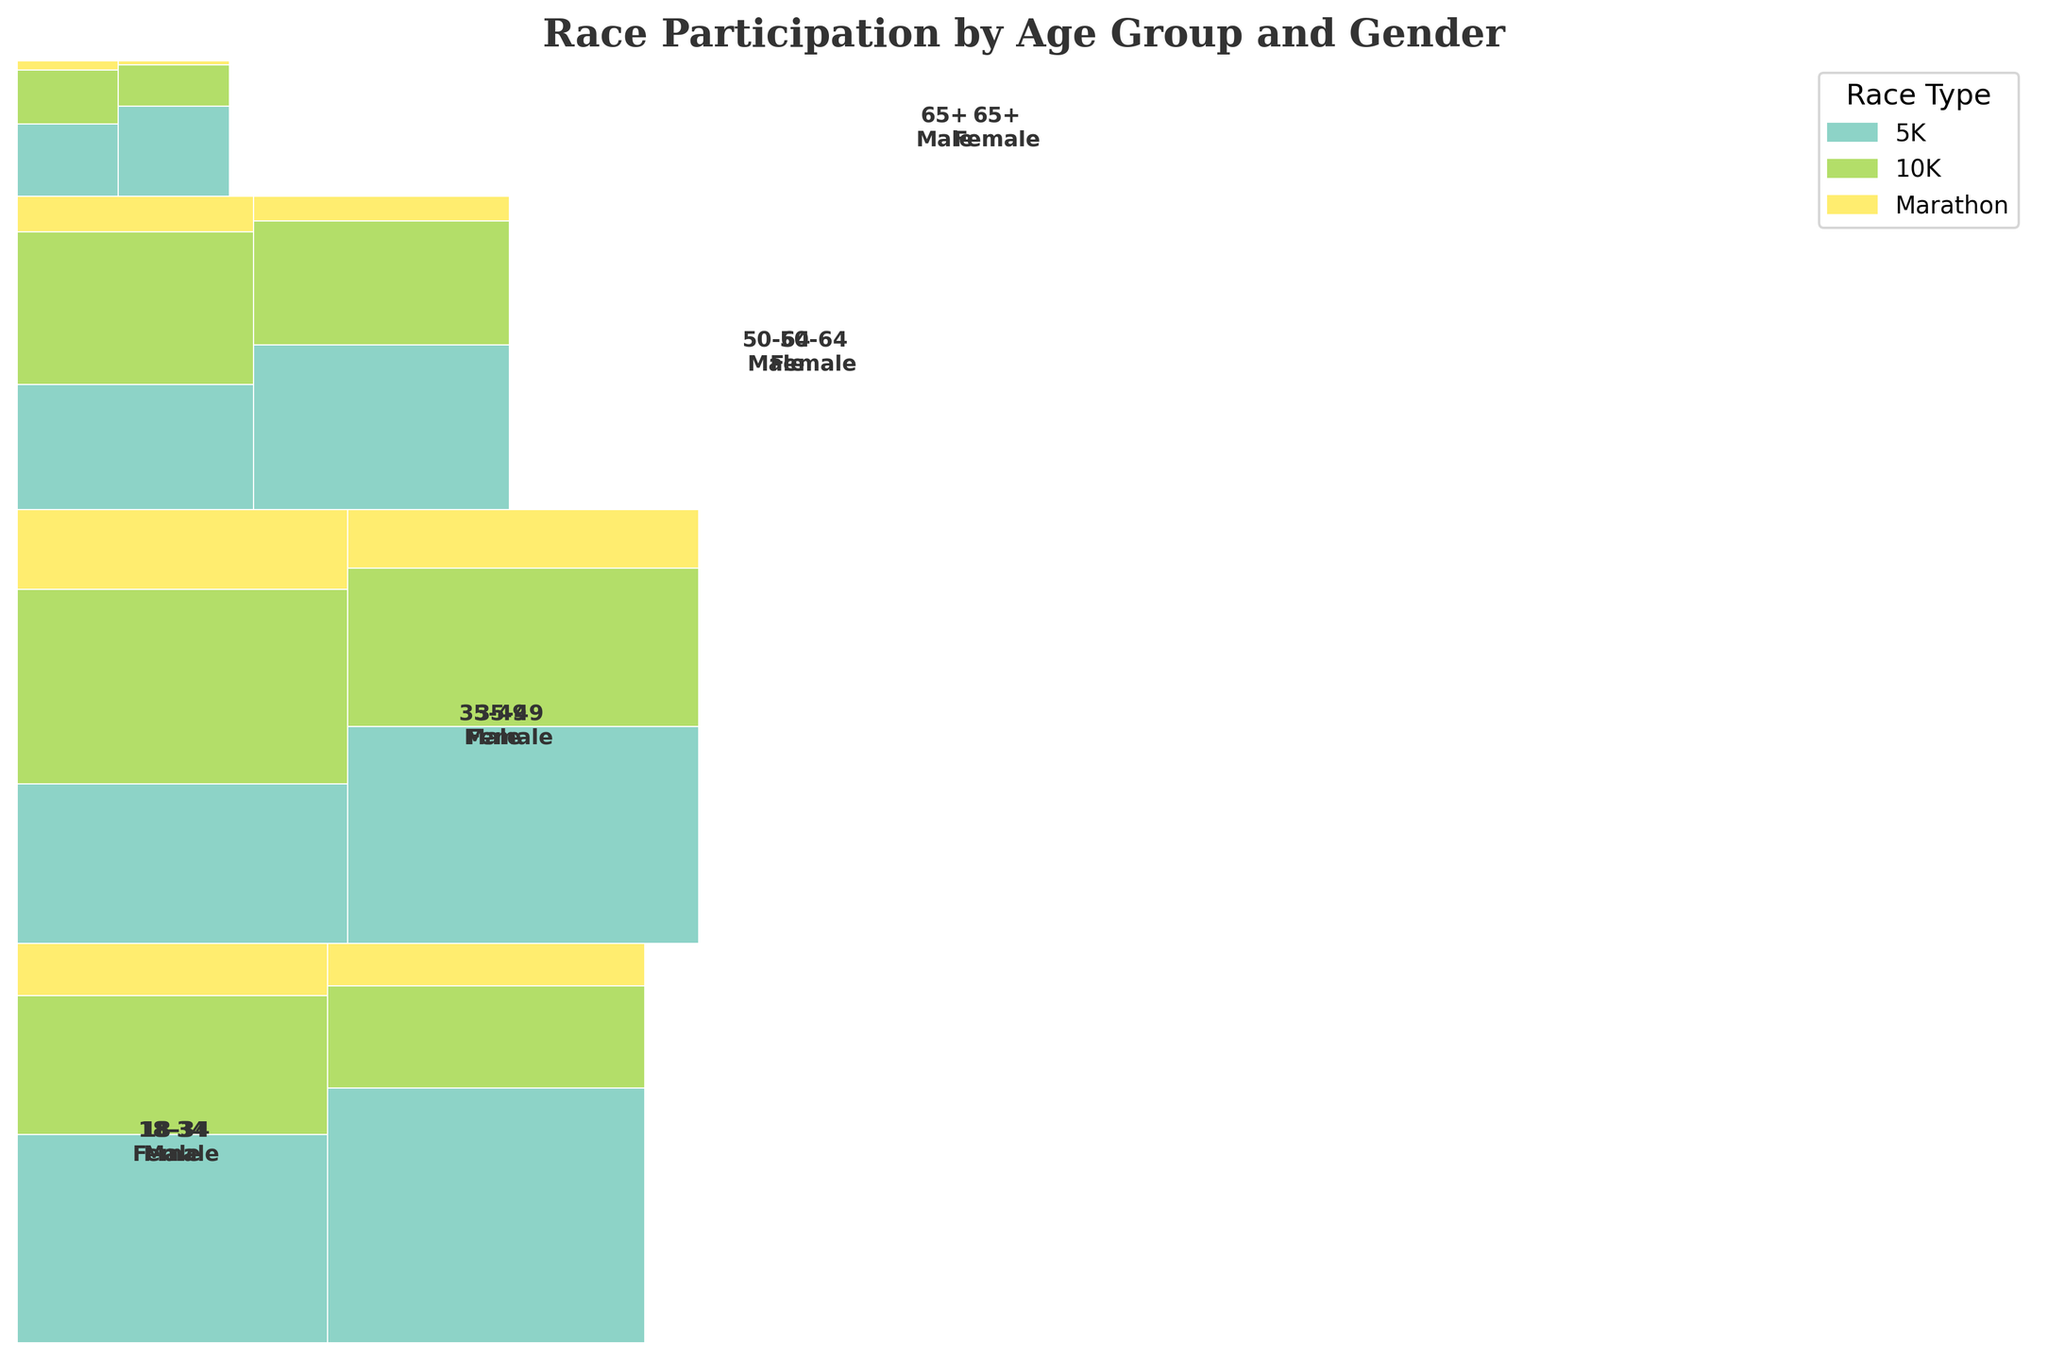Which age group has the highest overall participation in 5K races? To identify the age group with the highest participation in 5K races, compare the height of the 5K sections across different age groups in the mosaic plot. The tallest section corresponds to the 18-34 age group.
Answer: 18-34 Which gender has more participation in marathons for the 35-49 age group? Compare the rectangular areas representing marathon participation for males and females within the 35-49 age group. The larger area belongs to the males.
Answer: Male How does the number of 10K participants in the 65+ age group compare between genders? To compare participation, observe the sections for males and females in the 65+ age group related to 10K races. The male section is larger than the female section.
Answer: More males Which race type has the least participation among females aged 50-64? Look at the sections for females in the 50-64 age group and find the smallest one, which is for the marathon.
Answer: Marathon What is the combined participation in marathons for the age groups 50-64 and 65+ for females? Combine the marathon participation numbers for females in the 50-64 and 65+ age groups (150+25).
Answer: 175 Between 18-34 and 50-64 age groups, which one has a higher participation in 5K races regardless of gender? Sum up the participation numbers for both genders in the 5K races for each age group and compare them. The 18-34 age group has a larger sum (1200+1500 > 700+1000).
Answer: 18-34 In the 35-49 age group, compare the participation in 10K races between genders. Observe the areas for 10K races within the 35-49 age group for both genders, where males slightly have a larger section than females (1100 > 950).
Answer: Males In the 18-34 age group, which gender has more total participation in all race types? Aggregate the participation numbers across all race types for both genders and compare them. Females have more total participation (1500+600+250 = 2350 vs. 1200+800+300 = 2300).
Answer: Female What proportion of the total participation in 5K races does the 65+ age group account for? Sum up the 5K participation for all age groups and calculate the proportion for the 65+ age group (400+550)/(1200+1500+900+1300+700+1000+400+550) ≈ 0.086 or 8.6%.
Answer: 8.6% How does the marathon participation for males aged 35-49 compare to males aged 18-34? Compare the marathon participation numbers for males in both age groups (450 > 300).
Answer: 35-49 